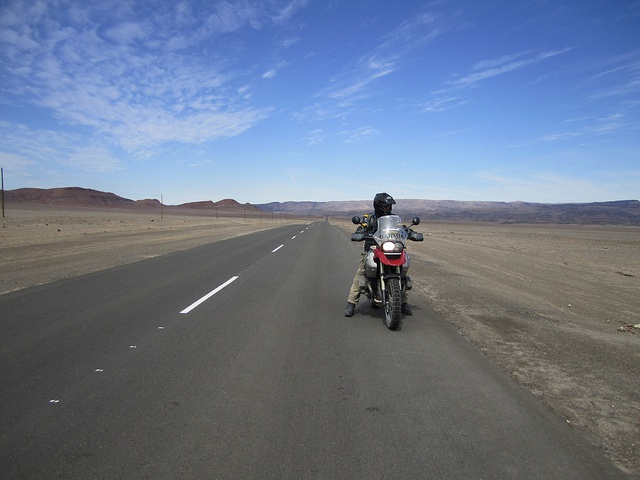Describe the objects in this image and their specific colors. I can see motorcycle in blue, black, gray, darkgray, and lightgray tones and people in blue, black, gray, and darkblue tones in this image. 